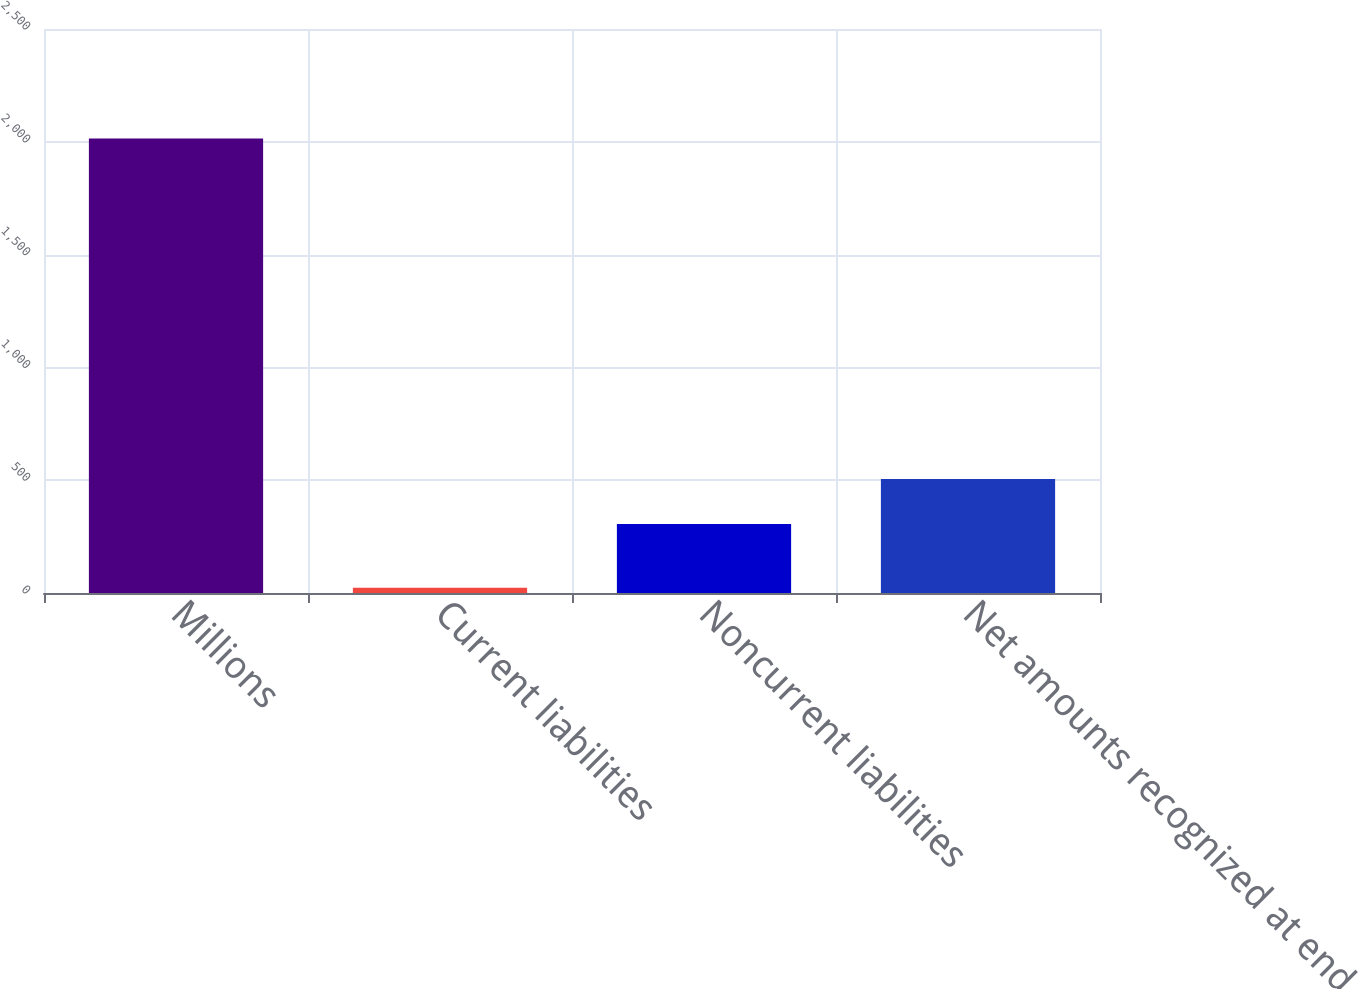Convert chart to OTSL. <chart><loc_0><loc_0><loc_500><loc_500><bar_chart><fcel>Millions<fcel>Current liabilities<fcel>Noncurrent liabilities<fcel>Net amounts recognized at end<nl><fcel>2015<fcel>23<fcel>306<fcel>505.2<nl></chart> 